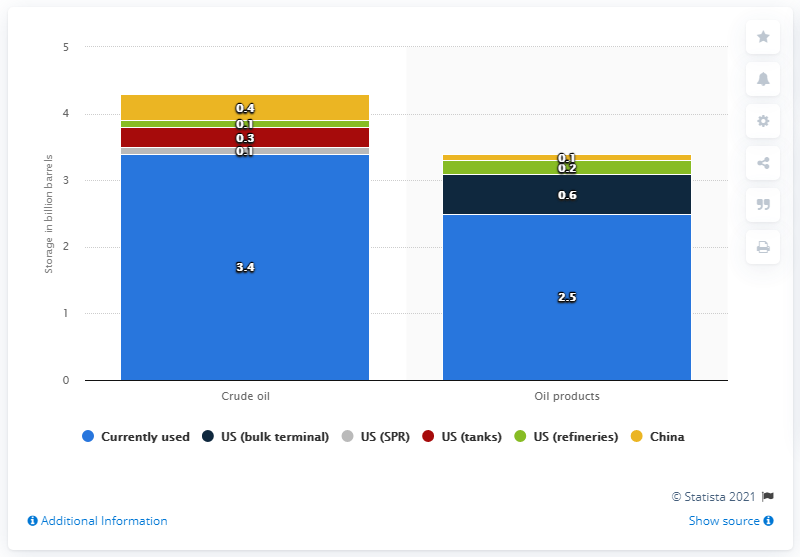Indicate a few pertinent items in this graphic. As of March 2020, approximately 3.4 billion barrels of crude oil storage were in use worldwide. 